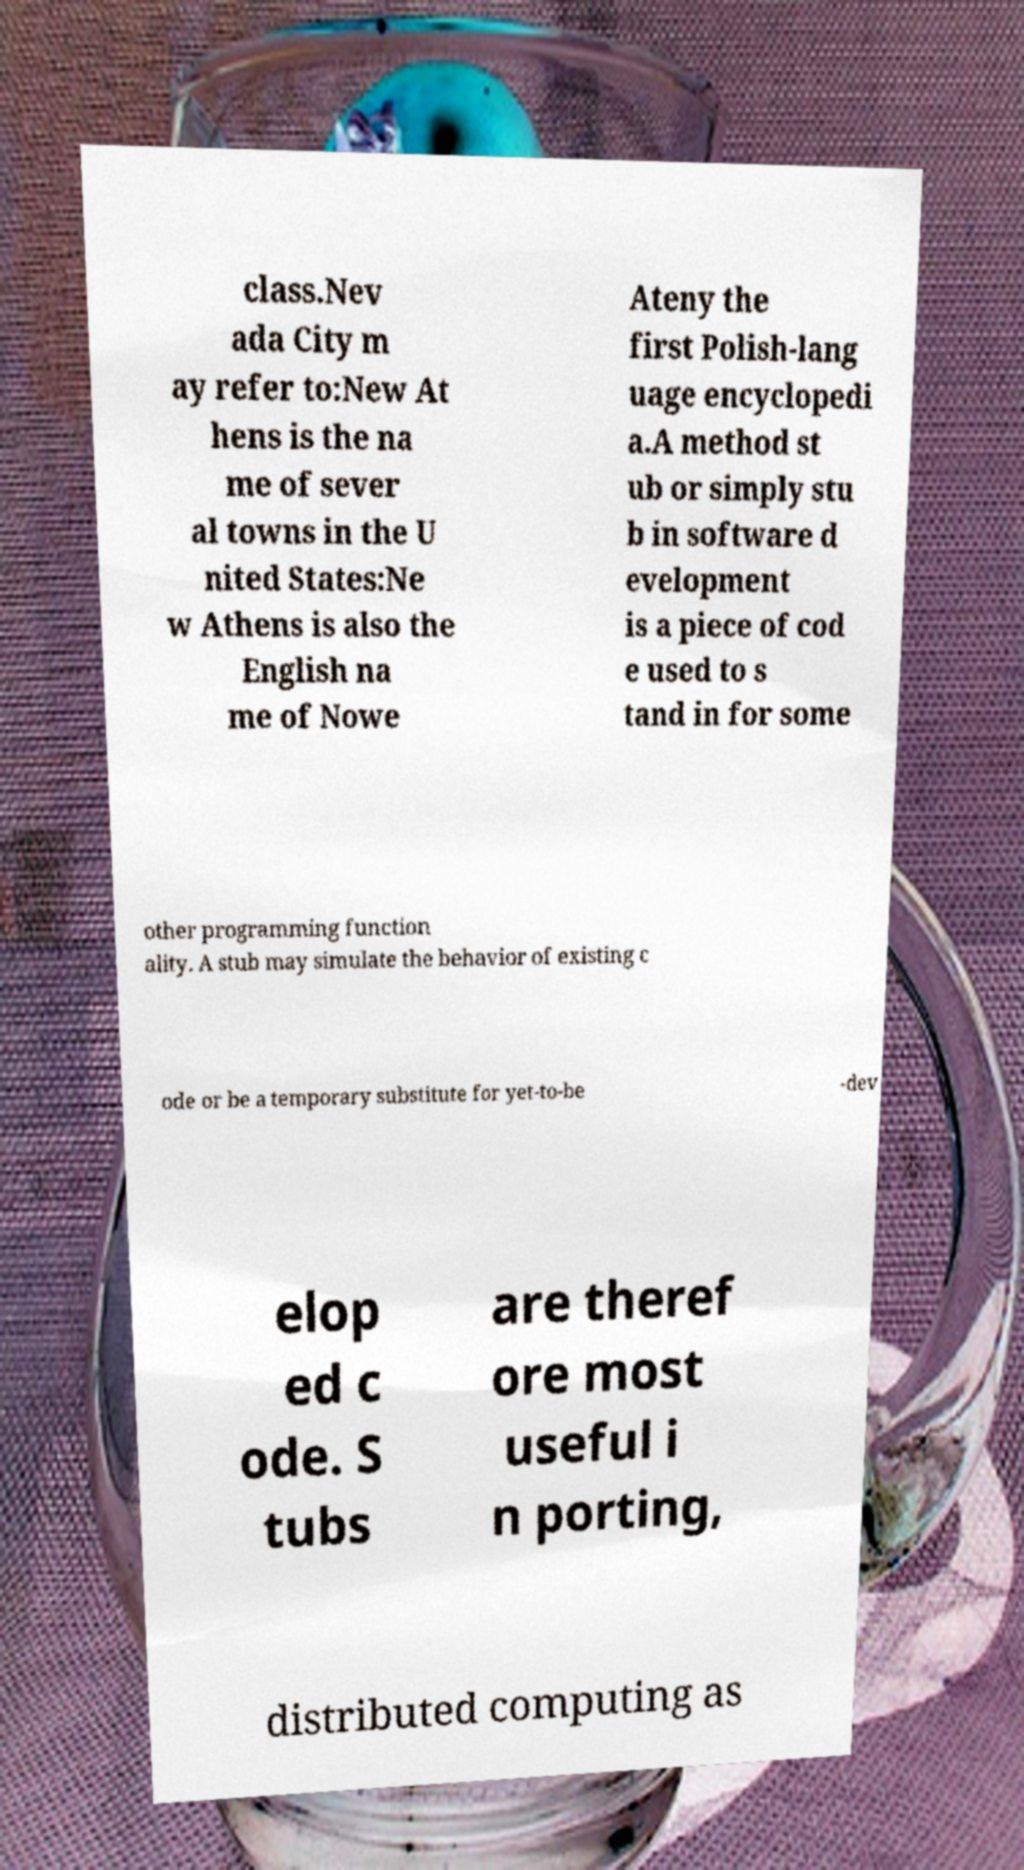What messages or text are displayed in this image? I need them in a readable, typed format. class.Nev ada City m ay refer to:New At hens is the na me of sever al towns in the U nited States:Ne w Athens is also the English na me of Nowe Ateny the first Polish-lang uage encyclopedi a.A method st ub or simply stu b in software d evelopment is a piece of cod e used to s tand in for some other programming function ality. A stub may simulate the behavior of existing c ode or be a temporary substitute for yet-to-be -dev elop ed c ode. S tubs are theref ore most useful i n porting, distributed computing as 